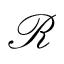<formula> <loc_0><loc_0><loc_500><loc_500>\ m a t h s c r { R }</formula> 